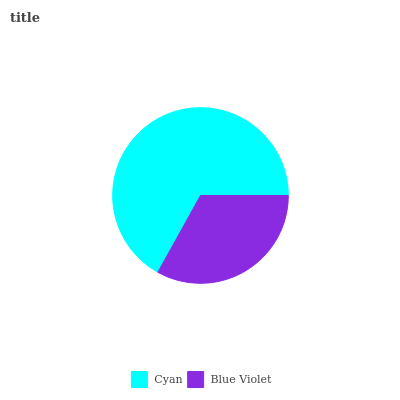Is Blue Violet the minimum?
Answer yes or no. Yes. Is Cyan the maximum?
Answer yes or no. Yes. Is Blue Violet the maximum?
Answer yes or no. No. Is Cyan greater than Blue Violet?
Answer yes or no. Yes. Is Blue Violet less than Cyan?
Answer yes or no. Yes. Is Blue Violet greater than Cyan?
Answer yes or no. No. Is Cyan less than Blue Violet?
Answer yes or no. No. Is Cyan the high median?
Answer yes or no. Yes. Is Blue Violet the low median?
Answer yes or no. Yes. Is Blue Violet the high median?
Answer yes or no. No. Is Cyan the low median?
Answer yes or no. No. 